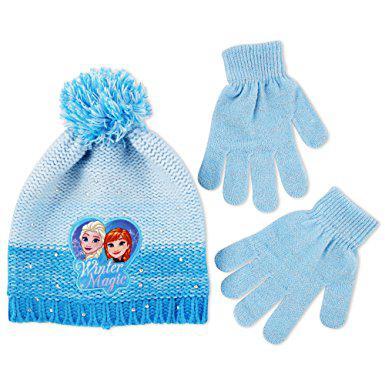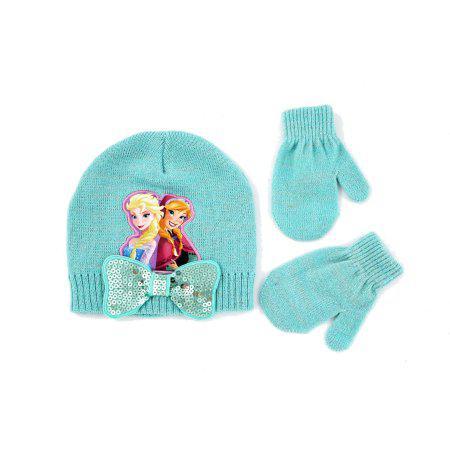The first image is the image on the left, the second image is the image on the right. For the images shown, is this caption "One of the images contains a blue beanie with two blue gloves." true? Answer yes or no. Yes. 